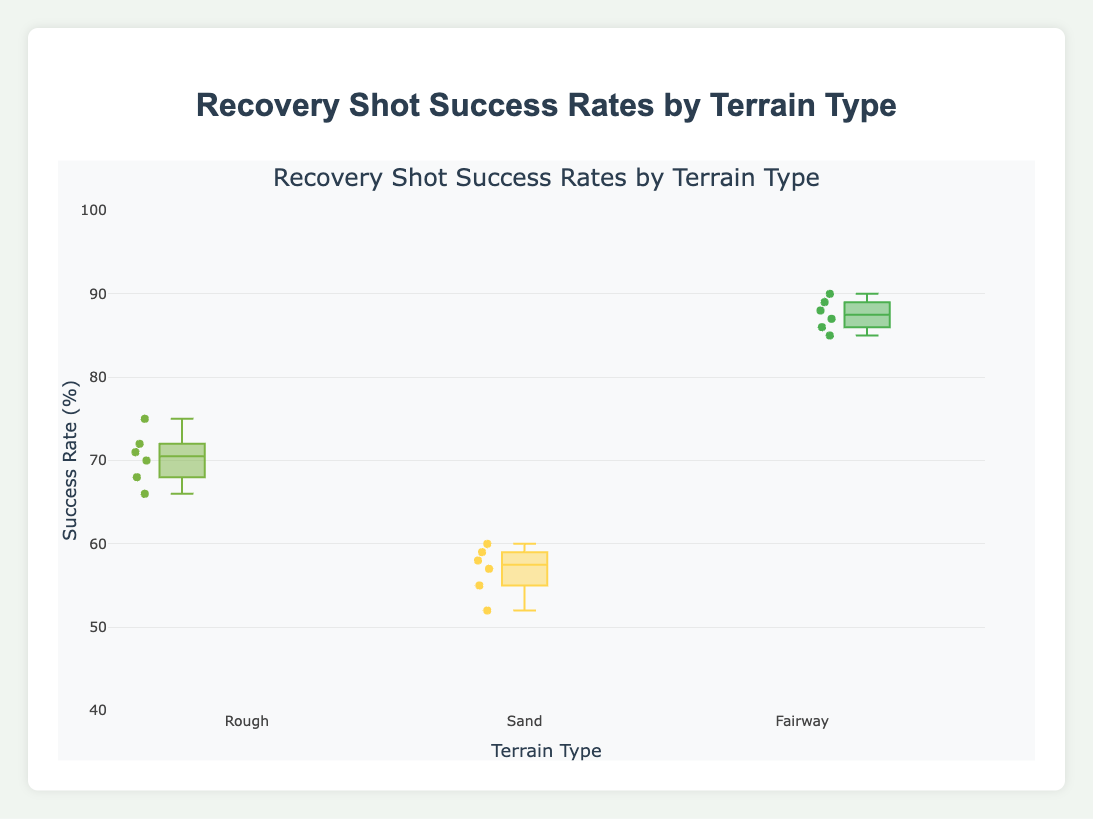What is the title of the plot? The title of the plot is usually found at the top of the plot. Here, it states "Recovery Shot Success Rates by Terrain Type."
Answer: Recovery Shot Success Rates by Terrain Type How many terrain types are represented in the plot? By observing the x-axis, we can see the labels representing different terrain types. There are three terrain types shown: Rough, Sand, and Fairway.
Answer: 3 Which terrain type has the highest median recovery shot success rate? By looking at the box plots, we can determine the median by the line inside each box. The Fairway has the highest median recovery shot success rate.
Answer: Fairway What is the range of success rates for the Rough terrain? The range can be determined by finding the minimum and maximum points in the box plot for Rough terrain. By observing the plot, the minimum is 66% and the maximum is 75%, giving a range.
Answer: 66%-75% What's the average of the median success rates for each terrain type? The median values for Rough, Sand, and Fairway are identified from the box plots. They are roughly 70%, 57%, and 88%. The average of these medians is (70 + 57 + 88) / 3.
Answer: (70 + 57 + 88) / 3 = 71.67% Which player has the highest success rate in the Rough terrain? By looking at the points plotted over the Rough terrain box plot, Rory McIlroy has the highest success rate of 75%.
Answer: Rory McIlroy Which terrain type shows the least variability in success rates? Variability can be assessed by the length of the box and the whiskers. The Fairway terrain has the shortest box and whiskers, indicating lower variability.
Answer: Fairway Compare the minimum success rates between Sand and Fairway terrains. Which is lower? By observing the lower whiskers of both box plots, the minimum success rate for Sand is 52%, and for Fairway, it is 85%. So, Sand is lower.
Answer: Sand What is the interquartile range (IQR) for the Sand terrain type? The IQR is found by subtracting the value at the lower quartile from the value at the upper quartile in the box plot. For Sand, these values are approximately 57% and 58%, giving an IQR.
Answer: 58% - 57% = 1% Is the median recovery shot success rate in Rough terrain greater than that in Sand terrain? The median is represented by the central line in each box plot. Comparing the Rough and Sand, the median in Rough is higher than in Sand.
Answer: Yes 